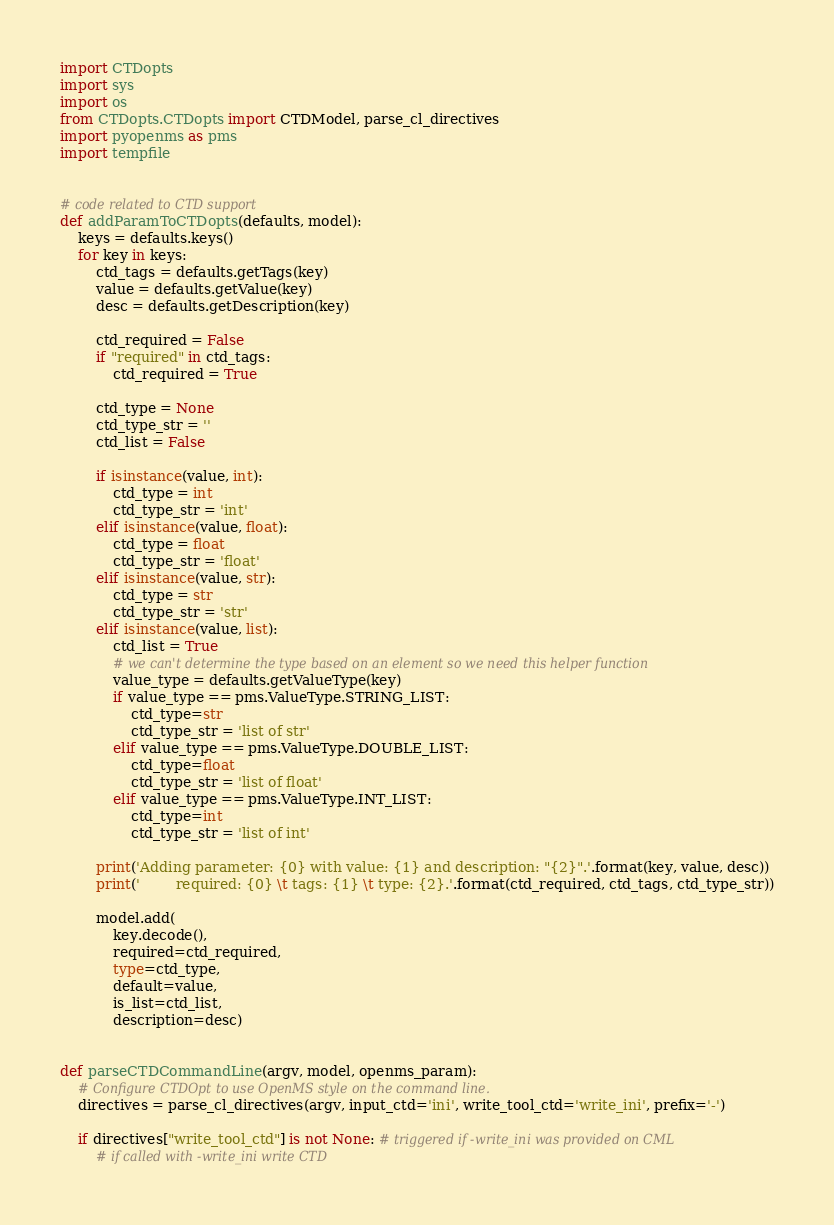<code> <loc_0><loc_0><loc_500><loc_500><_Python_>import CTDopts
import sys
import os
from CTDopts.CTDopts import CTDModel, parse_cl_directives
import pyopenms as pms
import tempfile


# code related to CTD support
def addParamToCTDopts(defaults, model):
    keys = defaults.keys()
    for key in keys:
        ctd_tags = defaults.getTags(key)
        value = defaults.getValue(key)
        desc = defaults.getDescription(key)

        ctd_required = False
        if "required" in ctd_tags:
            ctd_required = True

        ctd_type = None
        ctd_type_str = ''
        ctd_list = False

        if isinstance(value, int):
            ctd_type = int
            ctd_type_str = 'int'
        elif isinstance(value, float):
            ctd_type = float
            ctd_type_str = 'float'
        elif isinstance(value, str): 
            ctd_type = str
            ctd_type_str = 'str'
        elif isinstance(value, list):
            ctd_list = True
            # we can't determine the type based on an element so we need this helper function
            value_type = defaults.getValueType(key)
            if value_type == pms.ValueType.STRING_LIST:
                ctd_type=str
                ctd_type_str = 'list of str'
            elif value_type == pms.ValueType.DOUBLE_LIST:
                ctd_type=float
                ctd_type_str = 'list of float'
            elif value_type == pms.ValueType.INT_LIST:
                ctd_type=int
                ctd_type_str = 'list of int'

        print('Adding parameter: {0} with value: {1} and description: "{2}".'.format(key, value, desc))
        print('        required: {0} \t tags: {1} \t type: {2}.'.format(ctd_required, ctd_tags, ctd_type_str))

        model.add(
            key.decode(),
            required=ctd_required,
            type=ctd_type,
            default=value,
            is_list=ctd_list,
            description=desc)


def parseCTDCommandLine(argv, model, openms_param):
    # Configure CTDOpt to use OpenMS style on the command line.
    directives = parse_cl_directives(argv, input_ctd='ini', write_tool_ctd='write_ini', prefix='-')

    if directives["write_tool_ctd"] is not None: # triggered if -write_ini was provided on CML
        # if called with -write_ini write CTD</code> 